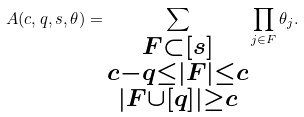Convert formula to latex. <formula><loc_0><loc_0><loc_500><loc_500>A ( c , q , s , \theta ) = \sum _ { \substack { F \subset [ s ] \\ c - q \leq | F | \leq c \\ | F \cup [ q ] | \geq c } } \prod _ { j \in F } \theta _ { j } .</formula> 